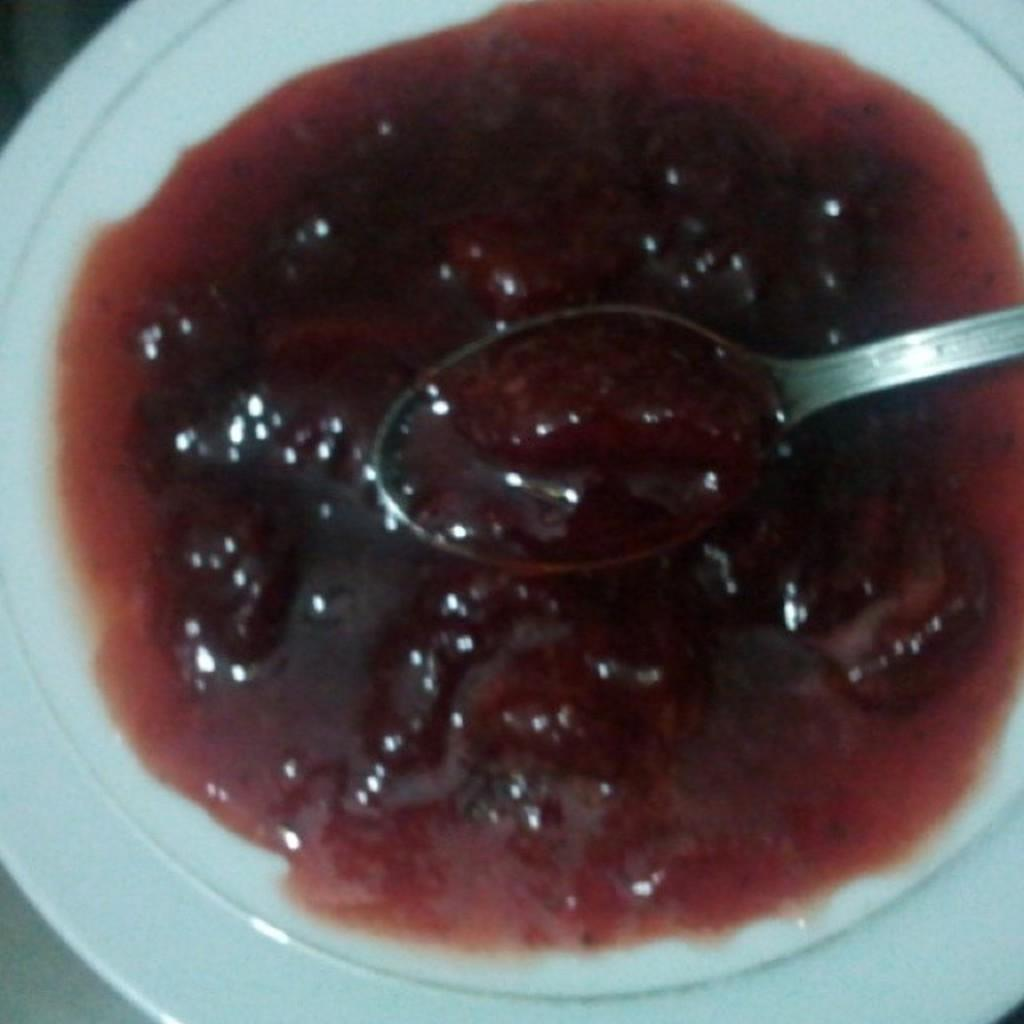What is present in the image related to eating? There is food and a spoon in the image. How are the food and spoon arranged in the image? The food and spoon are placed on a white plate. Where is the white plate located in the image? The white plate is placed on a platform. What type of quilt is being used to serve the food in the image? There is no quilt present in the image; the food is served on a white plate. 